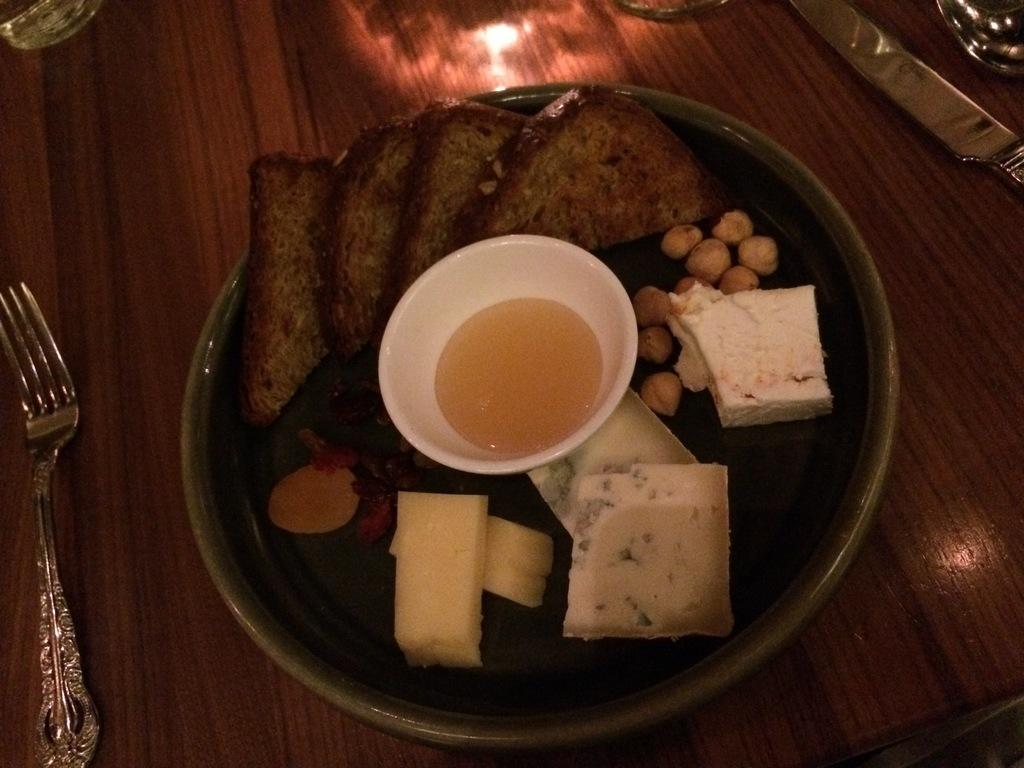What utensils are present on the table in the image? There is a knife and a fork on the table in the image. What else can be seen on the table besides utensils? There are other objects on the table, including a plate. What is on the plate? The plate contains food items. How many utensils are visible on the table? Two utensils, a knife and a fork, are visible on the table. What type of watch is the laborer wearing in the image? There is no laborer or watch present in the image. How many towns are visible in the image? There are no towns visible in the image. 